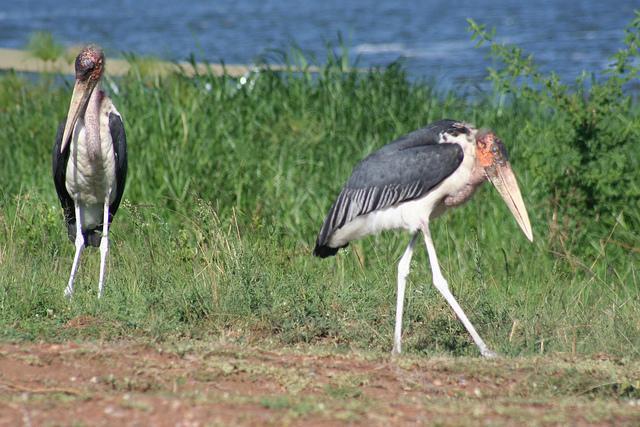How many birds are visible?
Give a very brief answer. 2. 